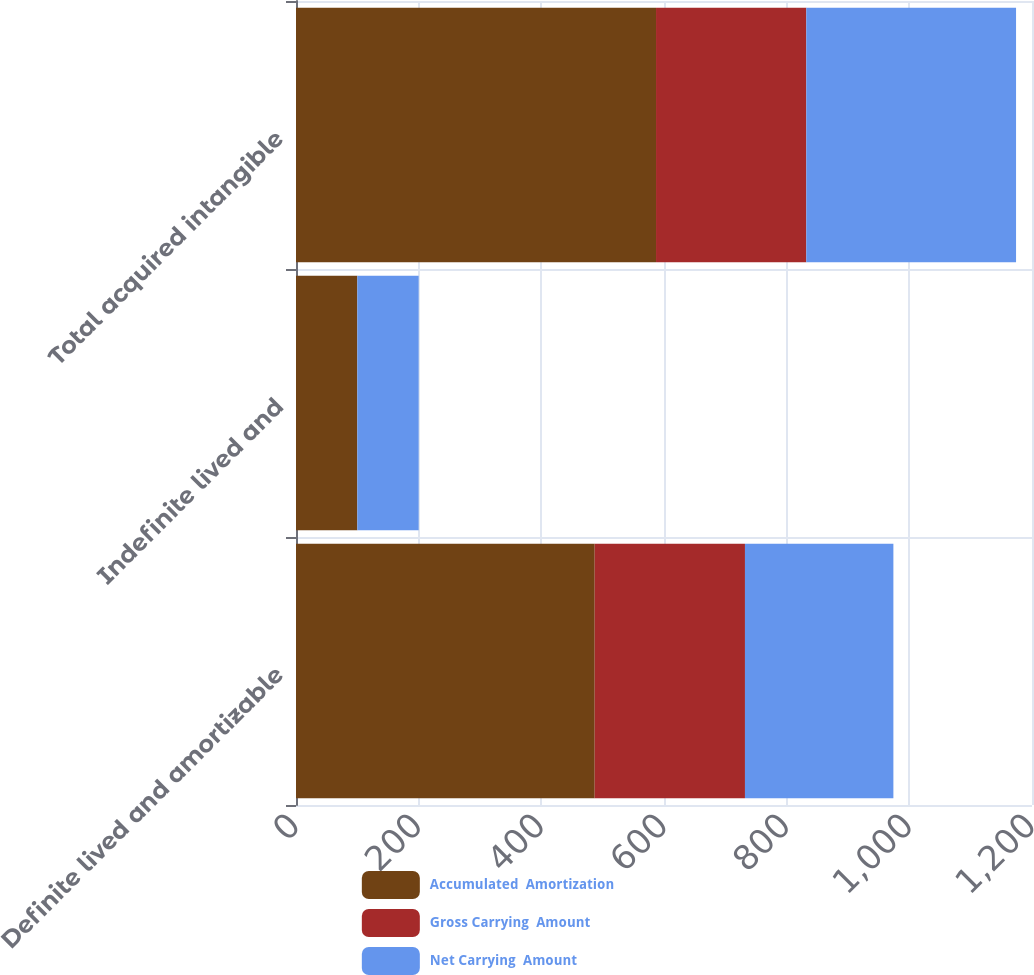<chart> <loc_0><loc_0><loc_500><loc_500><stacked_bar_chart><ecel><fcel>Definite lived and amortizable<fcel>Indefinite lived and<fcel>Total acquired intangible<nl><fcel>Accumulated  Amortization<fcel>487<fcel>100<fcel>587<nl><fcel>Gross Carrying  Amount<fcel>245<fcel>0<fcel>245<nl><fcel>Net Carrying  Amount<fcel>242<fcel>100<fcel>342<nl></chart> 